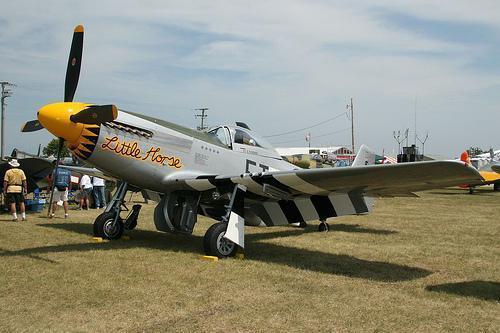How many planes is the picture capturing?
Give a very brief answer. 1. 